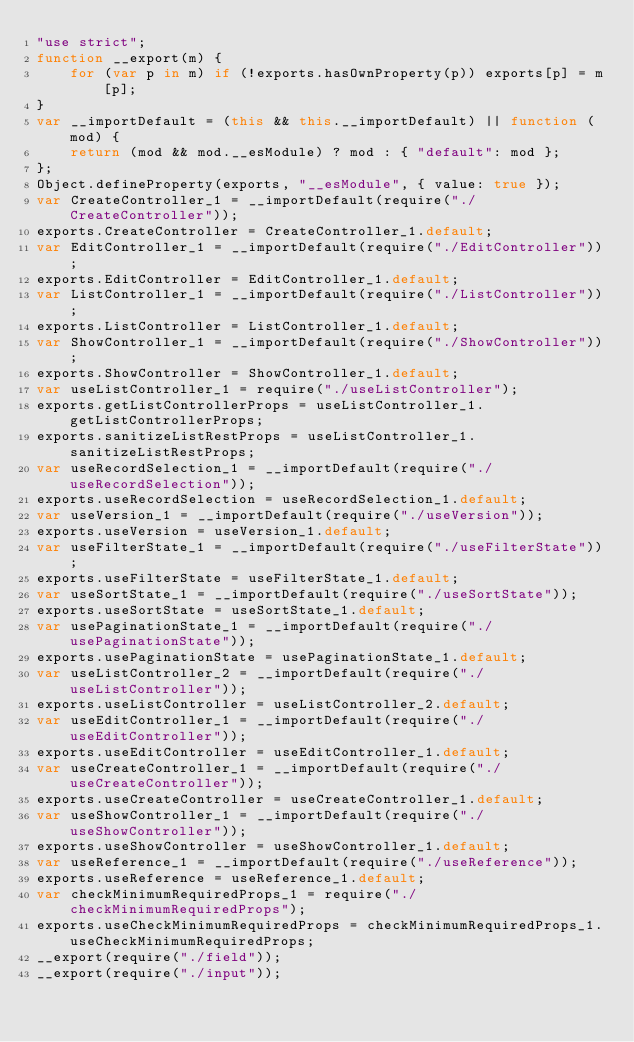<code> <loc_0><loc_0><loc_500><loc_500><_JavaScript_>"use strict";
function __export(m) {
    for (var p in m) if (!exports.hasOwnProperty(p)) exports[p] = m[p];
}
var __importDefault = (this && this.__importDefault) || function (mod) {
    return (mod && mod.__esModule) ? mod : { "default": mod };
};
Object.defineProperty(exports, "__esModule", { value: true });
var CreateController_1 = __importDefault(require("./CreateController"));
exports.CreateController = CreateController_1.default;
var EditController_1 = __importDefault(require("./EditController"));
exports.EditController = EditController_1.default;
var ListController_1 = __importDefault(require("./ListController"));
exports.ListController = ListController_1.default;
var ShowController_1 = __importDefault(require("./ShowController"));
exports.ShowController = ShowController_1.default;
var useListController_1 = require("./useListController");
exports.getListControllerProps = useListController_1.getListControllerProps;
exports.sanitizeListRestProps = useListController_1.sanitizeListRestProps;
var useRecordSelection_1 = __importDefault(require("./useRecordSelection"));
exports.useRecordSelection = useRecordSelection_1.default;
var useVersion_1 = __importDefault(require("./useVersion"));
exports.useVersion = useVersion_1.default;
var useFilterState_1 = __importDefault(require("./useFilterState"));
exports.useFilterState = useFilterState_1.default;
var useSortState_1 = __importDefault(require("./useSortState"));
exports.useSortState = useSortState_1.default;
var usePaginationState_1 = __importDefault(require("./usePaginationState"));
exports.usePaginationState = usePaginationState_1.default;
var useListController_2 = __importDefault(require("./useListController"));
exports.useListController = useListController_2.default;
var useEditController_1 = __importDefault(require("./useEditController"));
exports.useEditController = useEditController_1.default;
var useCreateController_1 = __importDefault(require("./useCreateController"));
exports.useCreateController = useCreateController_1.default;
var useShowController_1 = __importDefault(require("./useShowController"));
exports.useShowController = useShowController_1.default;
var useReference_1 = __importDefault(require("./useReference"));
exports.useReference = useReference_1.default;
var checkMinimumRequiredProps_1 = require("./checkMinimumRequiredProps");
exports.useCheckMinimumRequiredProps = checkMinimumRequiredProps_1.useCheckMinimumRequiredProps;
__export(require("./field"));
__export(require("./input"));
</code> 